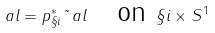Convert formula to latex. <formula><loc_0><loc_0><loc_500><loc_500>\ a l = p _ { \S i } ^ { * } \tilde { \ } a l \quad \text {on } \S i \times S ^ { 1 }</formula> 